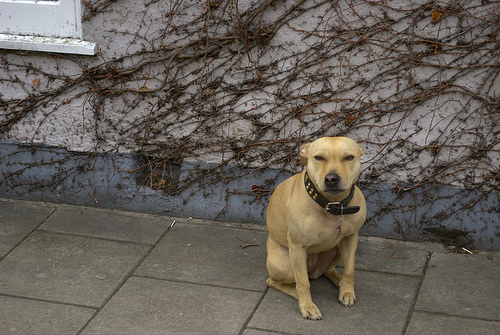Is the collar on a dog?
Answer the question using a single word or phrase. Yes What animal is it? Dog 